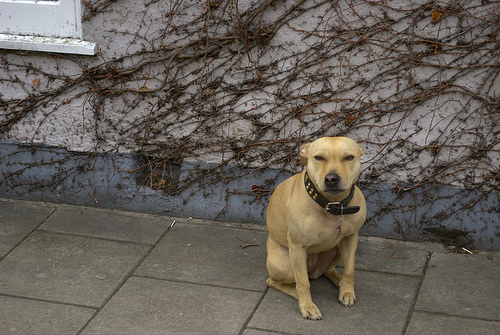Is the collar on a dog?
Answer the question using a single word or phrase. Yes What animal is it? Dog 